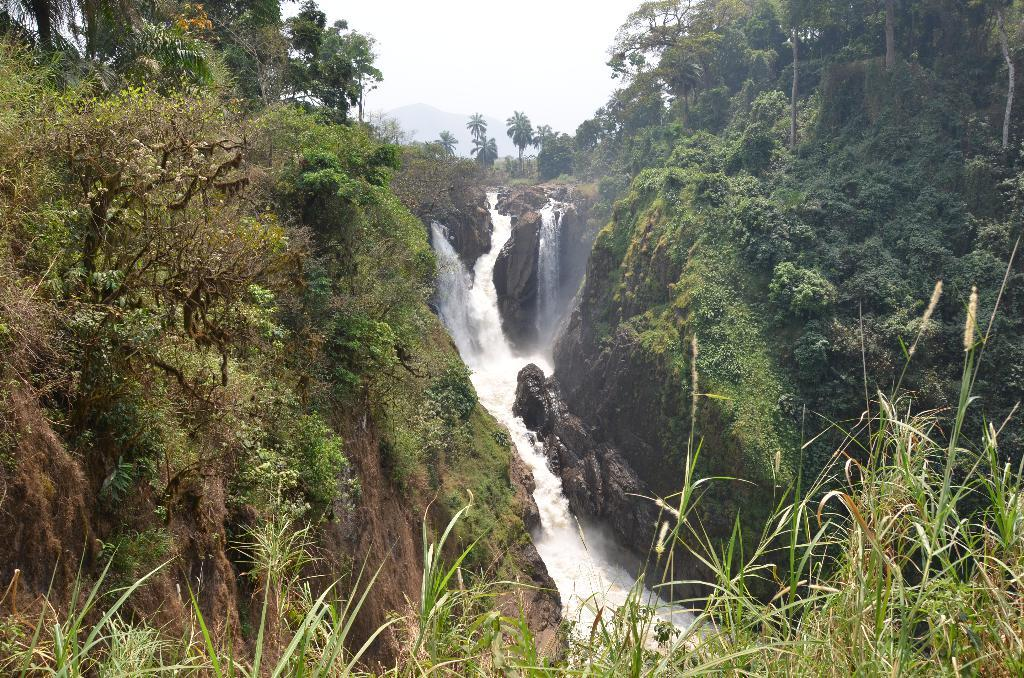What is the main feature in the center of the image? There is a waterfall in the center of the image. What can be seen in the background of the image? There are trees and hills in the background of the image. What type of vegetation is present in the image? There are plants in the image. What is visible at the top of the image? The sky is visible at the top of the image. What type of jelly can be seen on the grass in the image? There is no jelly or grass present in the image; it features a waterfall, trees, hills, plants, and the sky. 